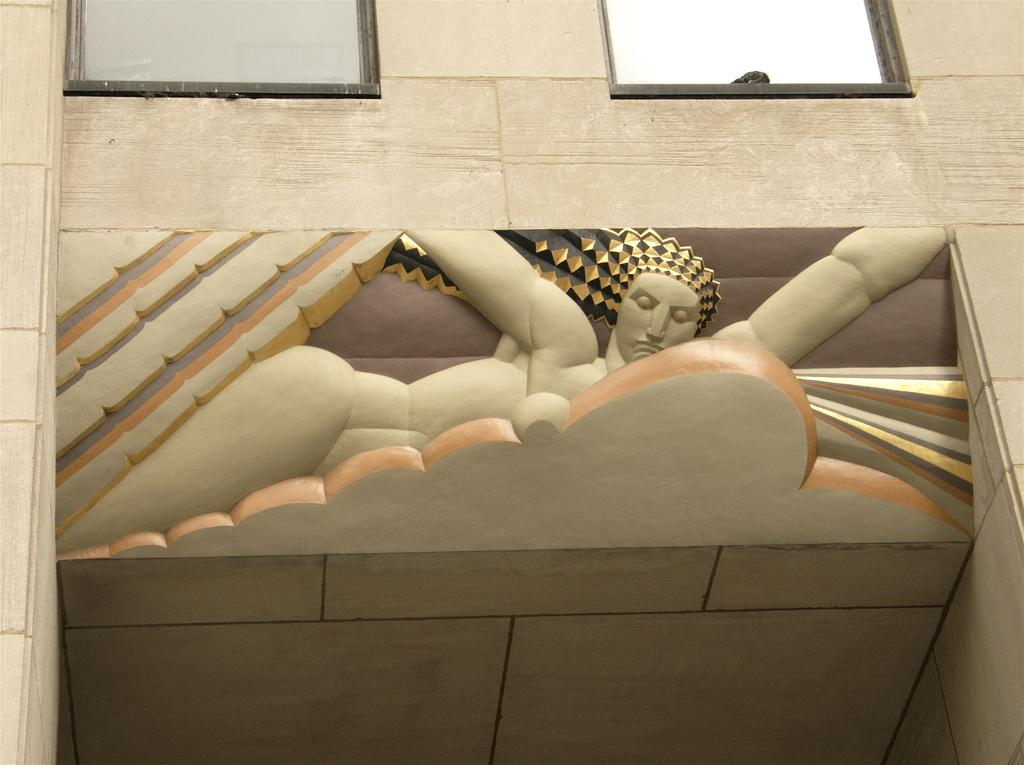What is the main subject in the center of the image? There is a sculpture on a building in the image, and it is in the center. What type of structure is the sculpture placed on? The sculpture is placed on a building. What can be seen at the top of the image? There are two glass windows at the top of the image. What type of soup is being served in the silver bowl in the image? There is no soup or silver bowl present in the image. 